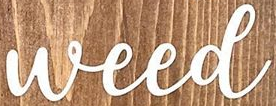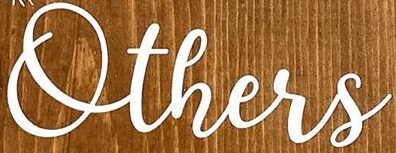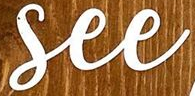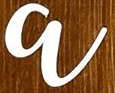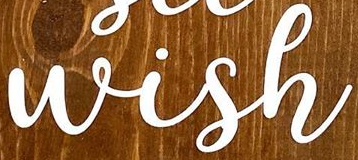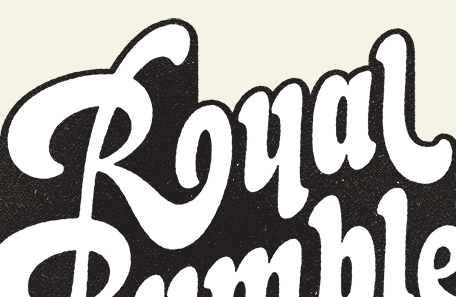What words are shown in these images in order, separated by a semicolon? Weed; Others; See; a; Wish; Rual 